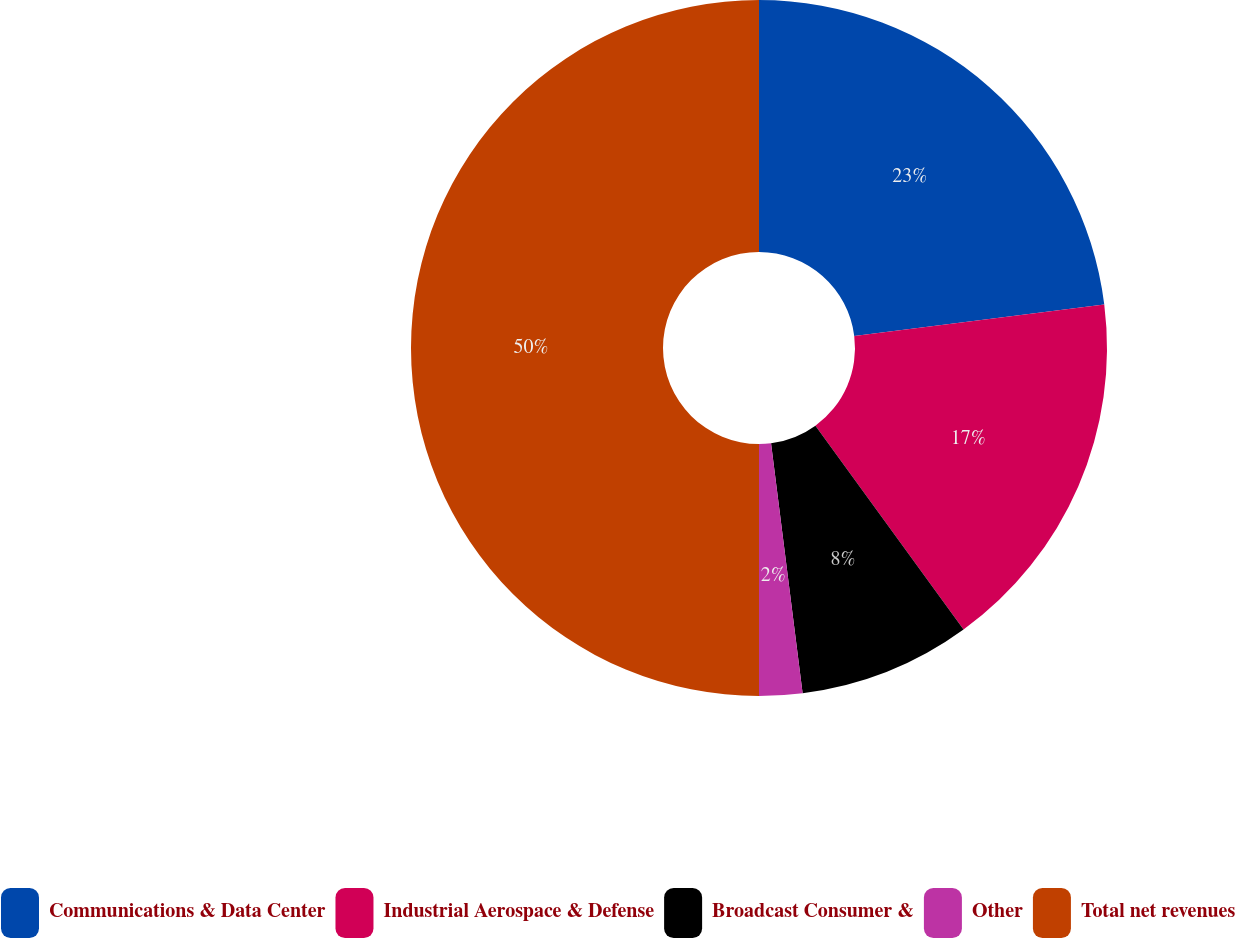Convert chart to OTSL. <chart><loc_0><loc_0><loc_500><loc_500><pie_chart><fcel>Communications & Data Center<fcel>Industrial Aerospace & Defense<fcel>Broadcast Consumer &<fcel>Other<fcel>Total net revenues<nl><fcel>23.0%<fcel>17.0%<fcel>8.0%<fcel>2.0%<fcel>50.0%<nl></chart> 